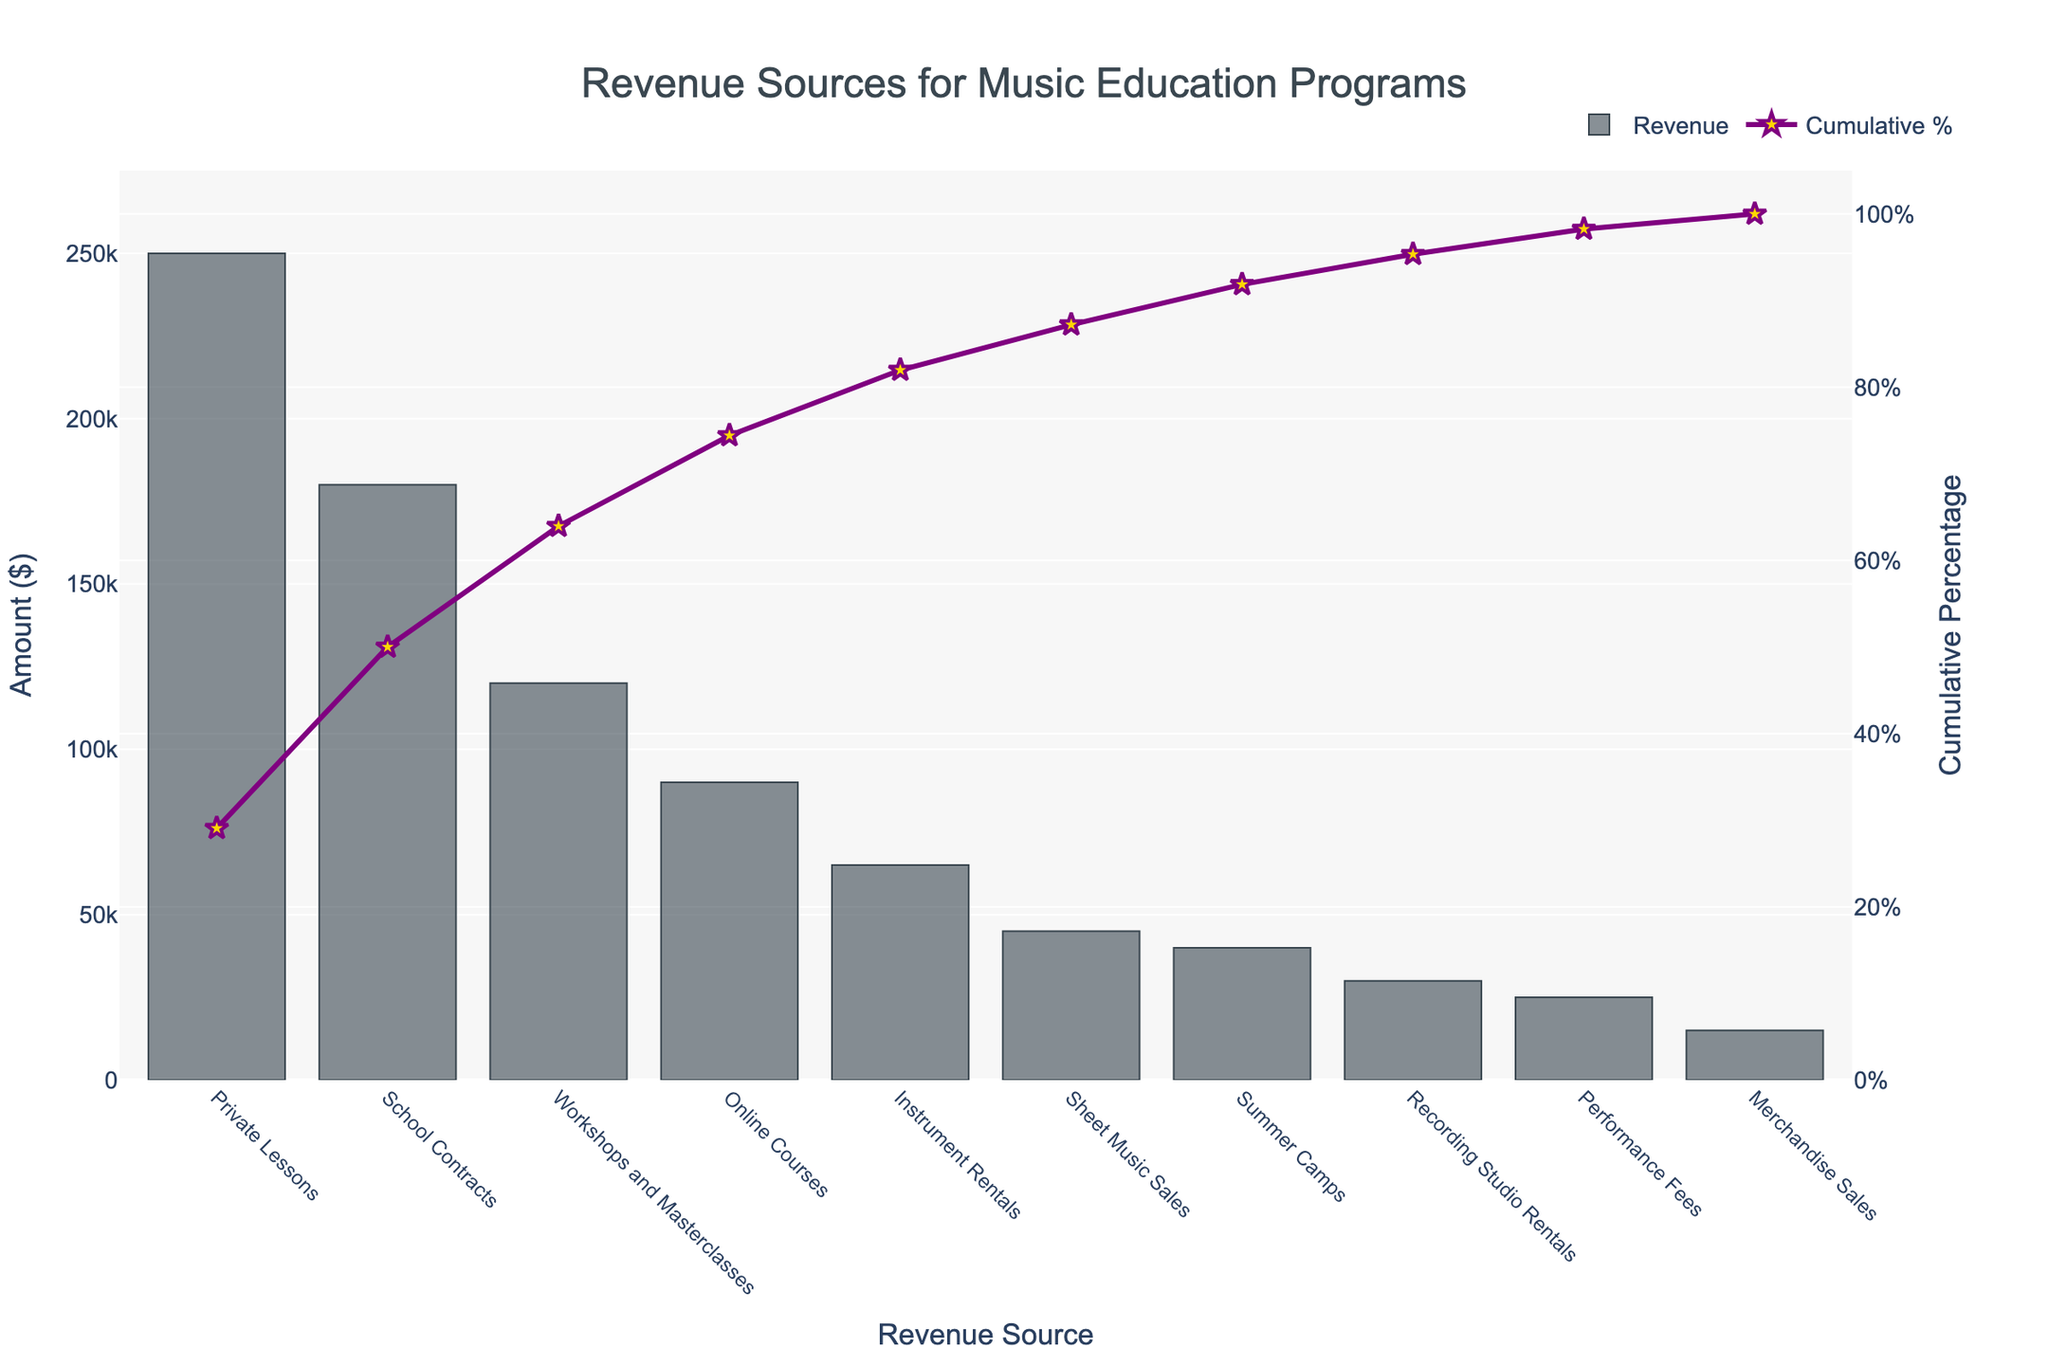What is the highest revenue source for music education programs? By looking at the bar chart, identify the bar that reaches the highest point, which represents the revenue source with the highest amount. The tallest bar corresponds to Private Lessons.
Answer: Private Lessons Which revenue source contributes the least amount? Observe the shortest bar on the bar chart, which represents the revenue source with the smallest contribution. The smallest bar corresponds to Merchandise Sales.
Answer: Merchandise Sales How much revenue is generated from Workshops and Masterclasses? Identify the bar labeled "Workshops and Masterclasses" in the bar chart and note its height or corresponding amount on the y-axis. The bar shows an amount of $120,000.
Answer: $120,000 What percentage of cumulative revenue is reached with the top three revenue sources? Sum the amounts of the top three revenue sources: Private Lessons ($250,000), School Contracts ($180,000), and Workshops and Masterclasses ($120,000). Then calculate the percentage of this total ($550,000) relative to the overall total revenue. The overall total revenue is $910,000, so the percentage is (550,000 / 910,000) * 100.
Answer: Approximately 60.44% What is the cumulative percentage of revenue after including Online Courses? Identify the cumulative percentage at the point where Online Courses is labeled. According to the data in the figure, this percentage is indicated by the position of the cumulative percentage line. It shows about 71%.
Answer: 71% Compare the revenue from Instrument Rentals and Performance Fees. Which one is higher and by how much? Look at the heights of the bars labeled "Instrument Rentals" and "Performance Fees." Instrument Rentals generate $65,000, while Performance Fees generate $25,000. Subtract the smaller from the larger amount: $65,000 - $25,000.
Answer: Instrument Rentals by $40,000 What fraction of the total revenue is contributed by the least three revenue sources combined? Identify the amounts from the three lowest revenue sources: Merchandise Sales ($15,000), Performance Fees ($25,000), and Recording Studio Rentals ($30,000). Sum these amounts: $15,000 + $25,000 + $30,000 = $70,000. Then, divide this by the total revenue, $910,000, and reduce the fraction.
Answer: 70,000 / 910,000, or approximately 7.7% How many revenue sources collectively make up at least 80% of the total revenue? Trace the cumulative percentage line and find the point where it first reaches or exceeds 80%. Count the number of revenue sources up to this point from the left. Four revenue sources (Private Lessons, School Contracts, Workshops and Masterclasses, Online Courses) together exceed 80%.
Answer: 4 Among Summer Camps and Sheet Music Sales, which contributes more to the revenue? Compare the heights of the bars labeled "Summer Camps" and "Sheet Music Sales." The bar for Sheet Music Sales is higher, representing $45,000, whereas Summer Camps represent $40,000.
Answer: Sheet Music Sales 